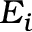<formula> <loc_0><loc_0><loc_500><loc_500>E _ { i }</formula> 